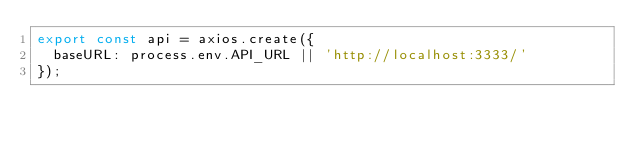<code> <loc_0><loc_0><loc_500><loc_500><_TypeScript_>export const api = axios.create({
  baseURL: process.env.API_URL || 'http://localhost:3333/'
});</code> 